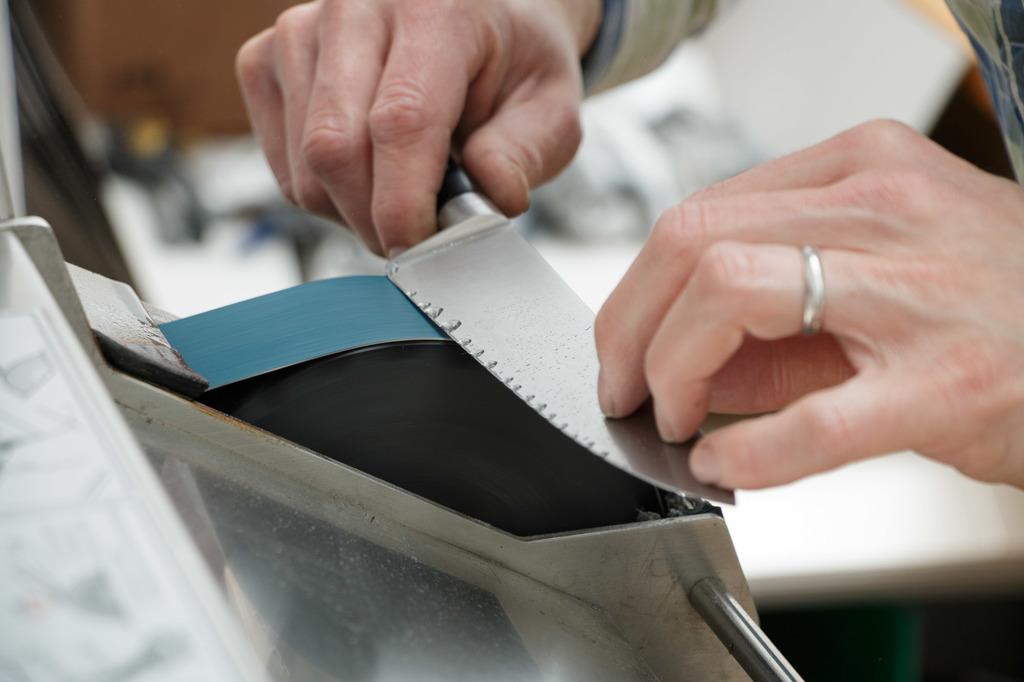Please provide a concise description of this image. In this image we can see the human hand sharpening the knife. 